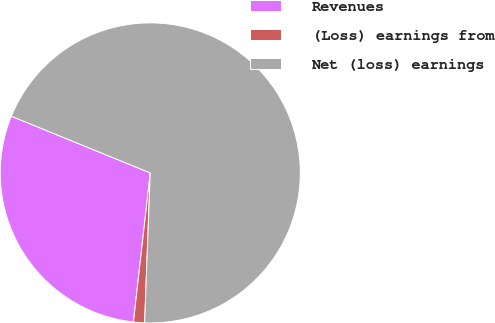Convert chart. <chart><loc_0><loc_0><loc_500><loc_500><pie_chart><fcel>Revenues<fcel>(Loss) earnings from<fcel>Net (loss) earnings<nl><fcel>29.38%<fcel>1.19%<fcel>69.43%<nl></chart> 